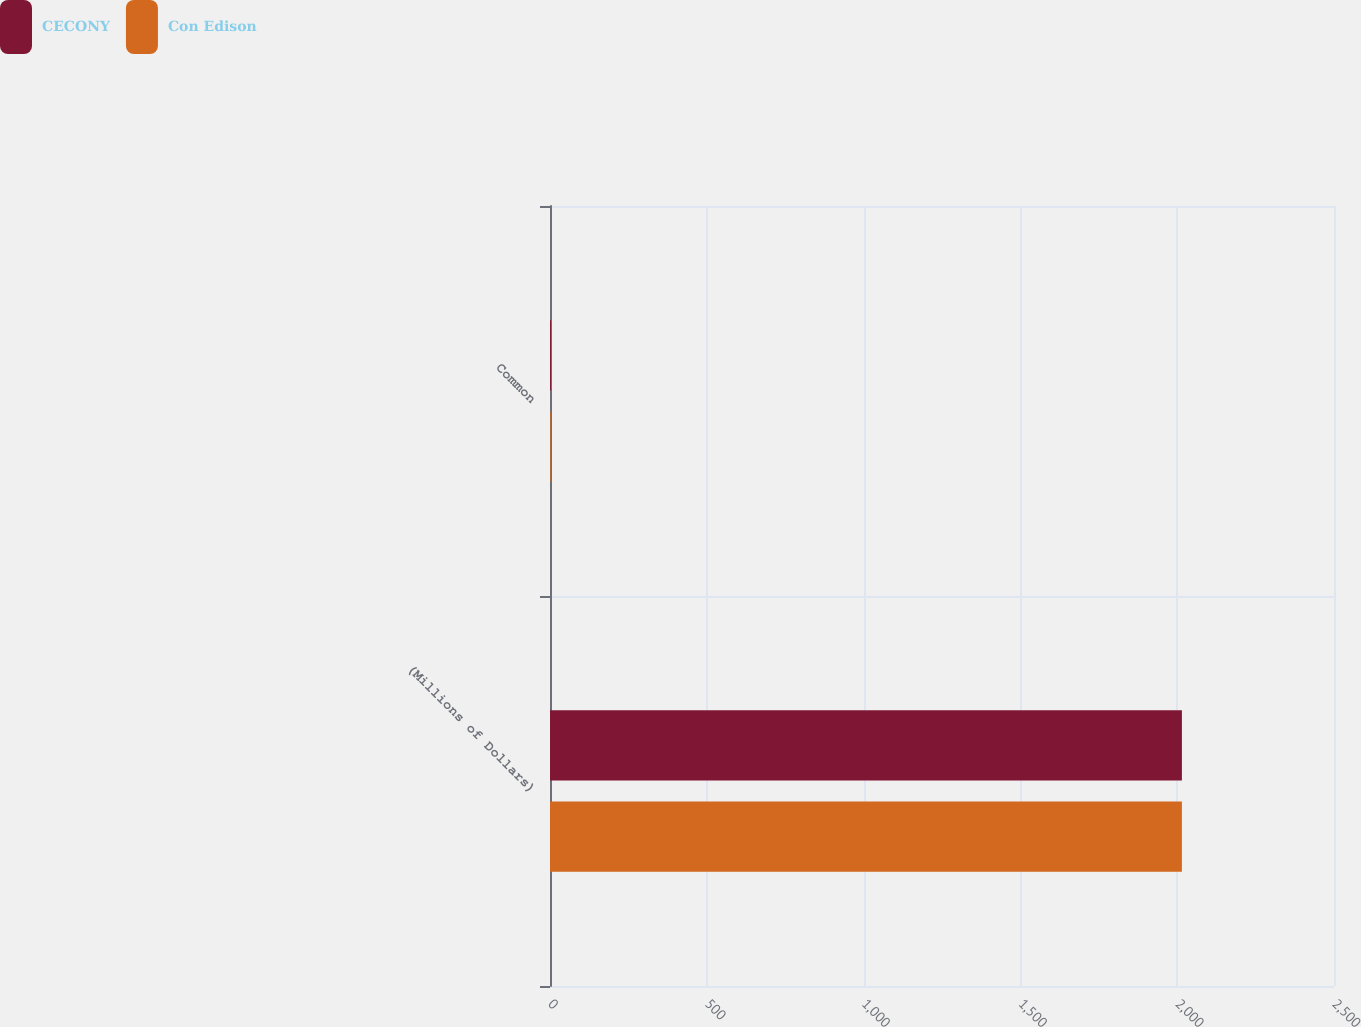<chart> <loc_0><loc_0><loc_500><loc_500><stacked_bar_chart><ecel><fcel>(Millions of Dollars)<fcel>Common<nl><fcel>CECONY<fcel>2015<fcel>3<nl><fcel>Con Edison<fcel>2015<fcel>2<nl></chart> 